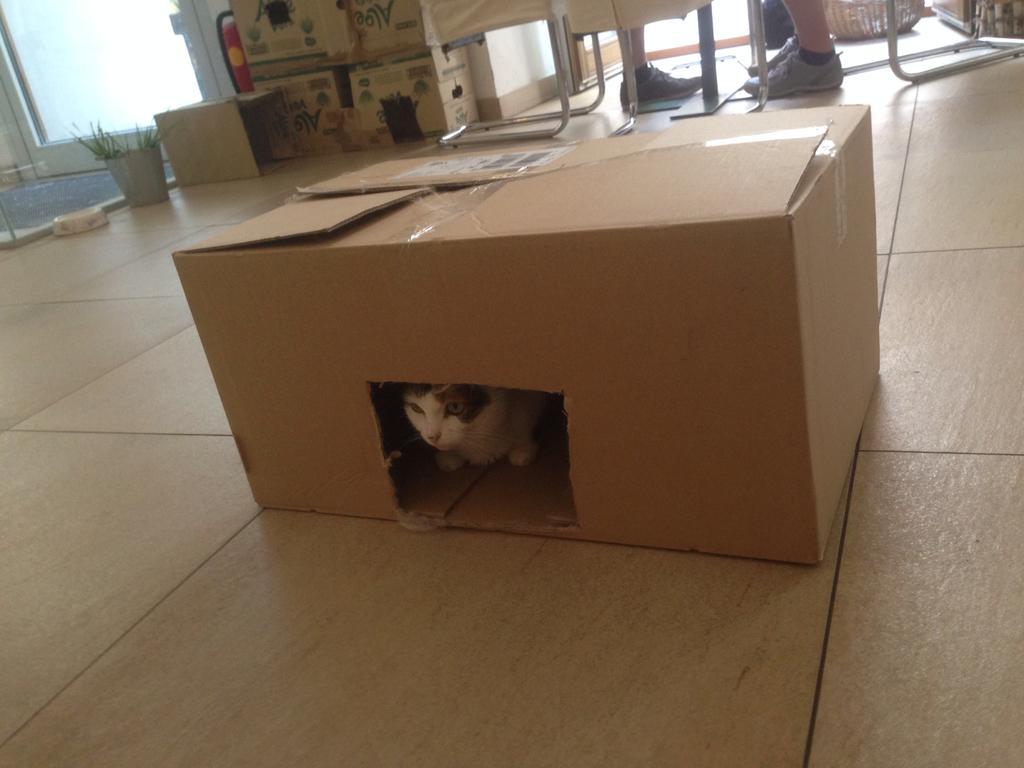How would you summarize this image in a sentence or two? In this image there are cardboard boxes and we can see a cat. We can see people's legs and there is a houseplant. On the left there is a door. 